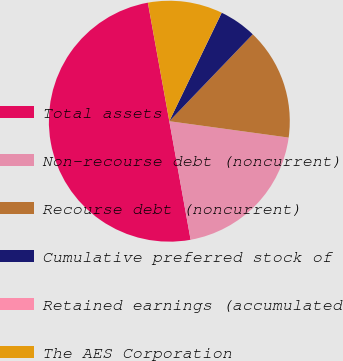Convert chart to OTSL. <chart><loc_0><loc_0><loc_500><loc_500><pie_chart><fcel>Total assets<fcel>Non-recourse debt (noncurrent)<fcel>Recourse debt (noncurrent)<fcel>Cumulative preferred stock of<fcel>Retained earnings (accumulated<fcel>The AES Corporation<nl><fcel>49.98%<fcel>20.0%<fcel>15.0%<fcel>5.01%<fcel>0.01%<fcel>10.0%<nl></chart> 